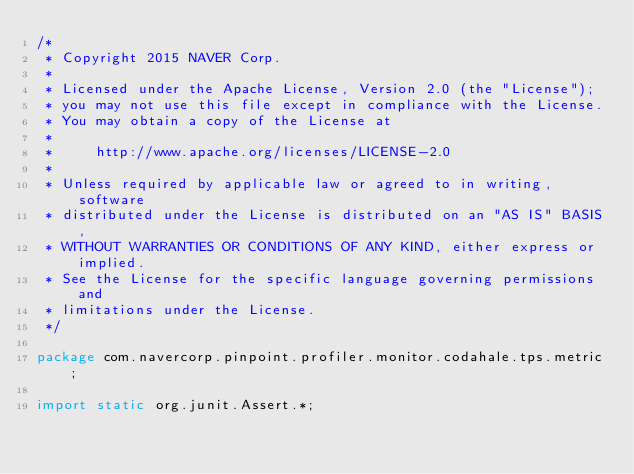Convert code to text. <code><loc_0><loc_0><loc_500><loc_500><_Java_>/*
 * Copyright 2015 NAVER Corp.
 *
 * Licensed under the Apache License, Version 2.0 (the "License");
 * you may not use this file except in compliance with the License.
 * You may obtain a copy of the License at
 *
 *     http://www.apache.org/licenses/LICENSE-2.0
 *
 * Unless required by applicable law or agreed to in writing, software
 * distributed under the License is distributed on an "AS IS" BASIS,
 * WITHOUT WARRANTIES OR CONDITIONS OF ANY KIND, either express or implied.
 * See the License for the specific language governing permissions and
 * limitations under the License.
 */

package com.navercorp.pinpoint.profiler.monitor.codahale.tps.metric;

import static org.junit.Assert.*;
</code> 